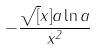<formula> <loc_0><loc_0><loc_500><loc_500>- \frac { \sqrt { [ } x ] { a } \ln a } { x ^ { 2 } }</formula> 